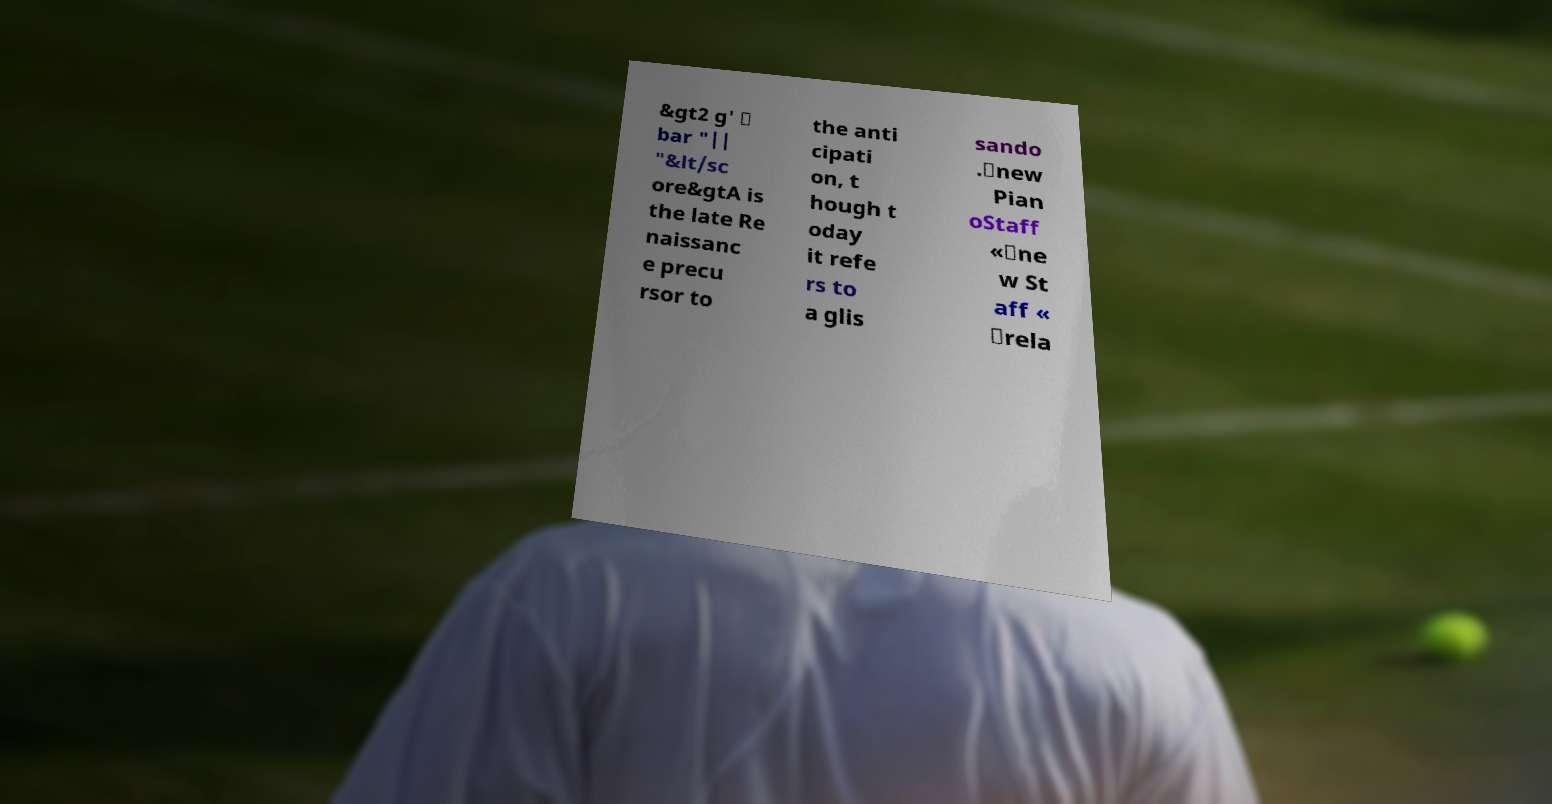Can you read and provide the text displayed in the image?This photo seems to have some interesting text. Can you extract and type it out for me? &gt2 g' \ bar "|| "&lt/sc ore&gtA is the late Re naissanc e precu rsor to the anti cipati on, t hough t oday it refe rs to a glis sando .\new Pian oStaff «\ne w St aff « \rela 